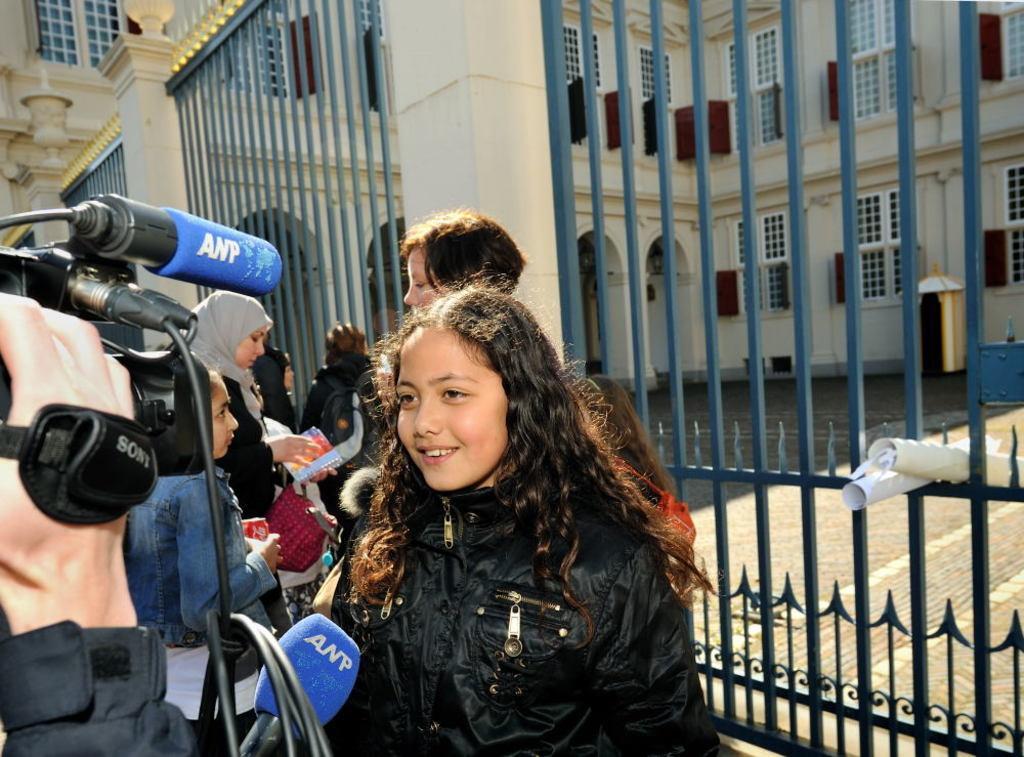Describe this image in one or two sentences. In this image I can see there are few persons visible In front of the gate and I can see the building in the middle and I can see a camera man holding a camera with his hand on the left side I can see a mike visible at the bottom. 